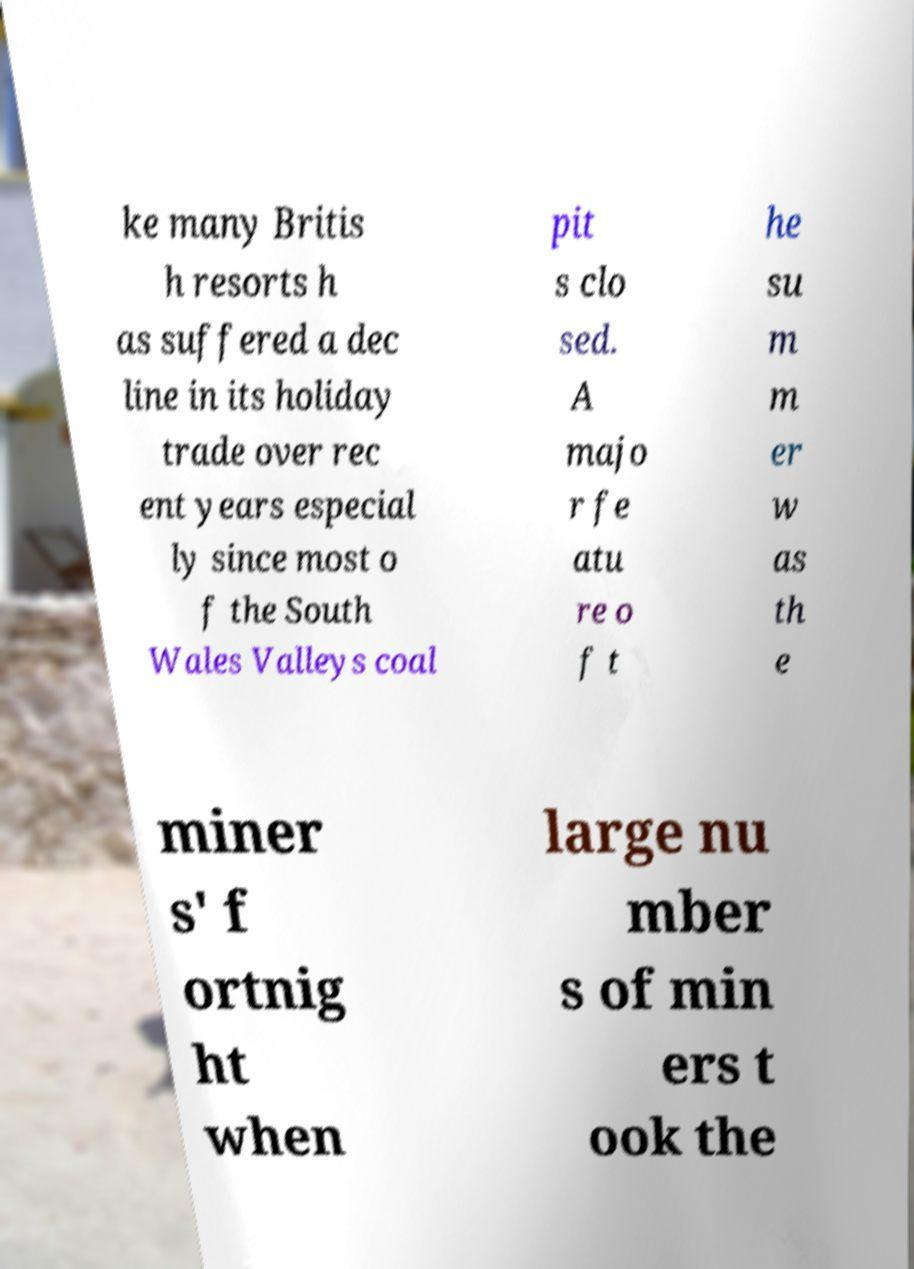Please read and relay the text visible in this image. What does it say? ke many Britis h resorts h as suffered a dec line in its holiday trade over rec ent years especial ly since most o f the South Wales Valleys coal pit s clo sed. A majo r fe atu re o f t he su m m er w as th e miner s' f ortnig ht when large nu mber s of min ers t ook the 